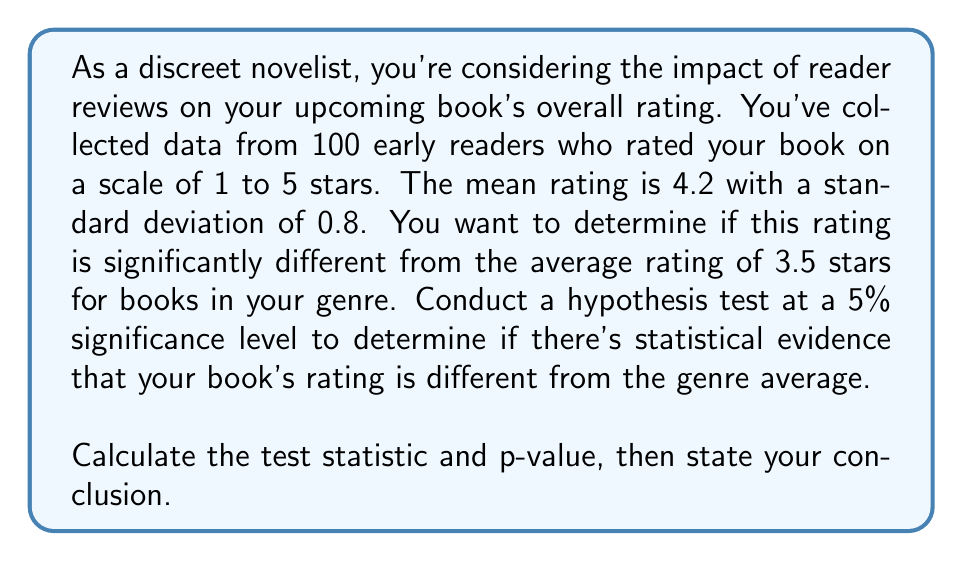Show me your answer to this math problem. To solve this problem, we'll use a one-sample t-test since we're comparing a sample mean to a population mean with an unknown population standard deviation.

Step 1: State the hypotheses
$H_0: \mu = 3.5$ (null hypothesis)
$H_a: \mu \neq 3.5$ (alternative hypothesis)

Step 2: Choose the significance level
$\alpha = 0.05$ (given in the question)

Step 3: Calculate the test statistic
The test statistic for a one-sample t-test is:

$t = \frac{\bar{x} - \mu_0}{s / \sqrt{n}}$

Where:
$\bar{x}$ = sample mean = 4.2
$\mu_0$ = hypothesized population mean = 3.5
$s$ = sample standard deviation = 0.8
$n$ = sample size = 100

Plugging in the values:

$t = \frac{4.2 - 3.5}{0.8 / \sqrt{100}} = \frac{0.7}{0.08} = 8.75$

Step 4: Calculate the degrees of freedom
$df = n - 1 = 100 - 1 = 99$

Step 5: Calculate the p-value
For a two-tailed test, we need to find $P(|T| > 8.75)$ where $T$ follows a t-distribution with 99 degrees of freedom.

Using a t-distribution calculator or table, we find that:
$p-value = 2 \times P(T > 8.75) \approx 2 \times (1.11 \times 10^{-13}) \approx 2.22 \times 10^{-13}$

Step 6: Compare the p-value to the significance level
$2.22 \times 10^{-13} < 0.05$

Since the p-value is less than the significance level, we reject the null hypothesis.

Step 7: State the conclusion
There is strong statistical evidence to conclude that the true mean rating of your book is significantly different from the genre average of 3.5 stars at the 5% significance level.
Answer: Test statistic: $t = 8.75$
P-value: $2.22 \times 10^{-13}$
Conclusion: Reject the null hypothesis. There is significant evidence that the book's rating differs from the genre average. 